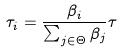<formula> <loc_0><loc_0><loc_500><loc_500>\tau _ { i } = \frac { \beta _ { i } } { \sum _ { j \in \Theta } \beta _ { j } } \tau</formula> 